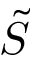Convert formula to latex. <formula><loc_0><loc_0><loc_500><loc_500>\tilde { S }</formula> 